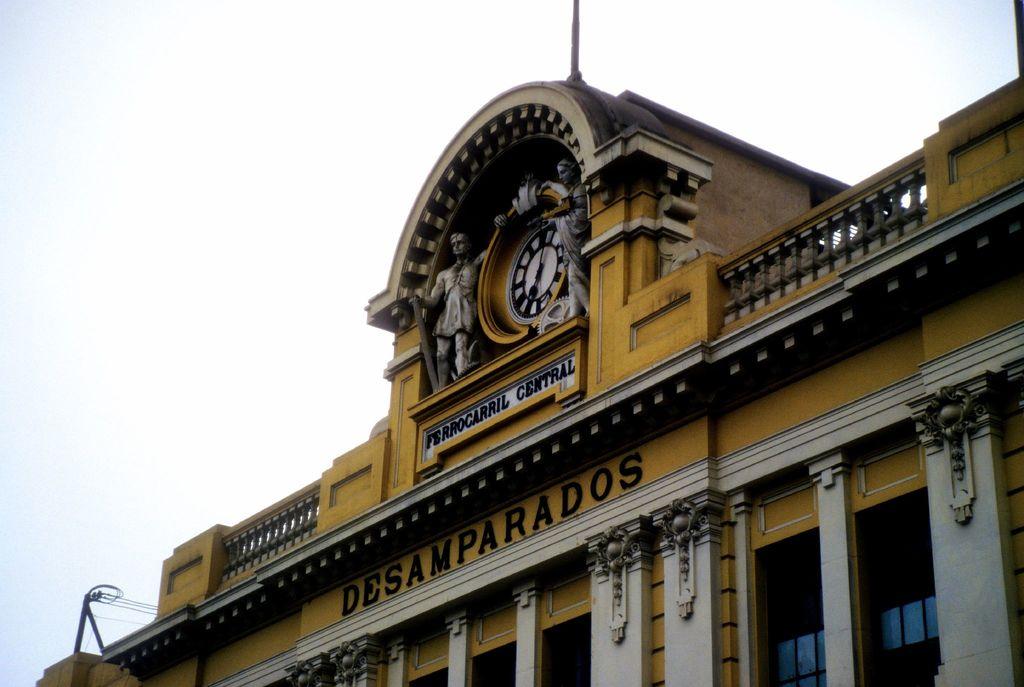What is written on the building facade?
Your response must be concise. Desamparados. 